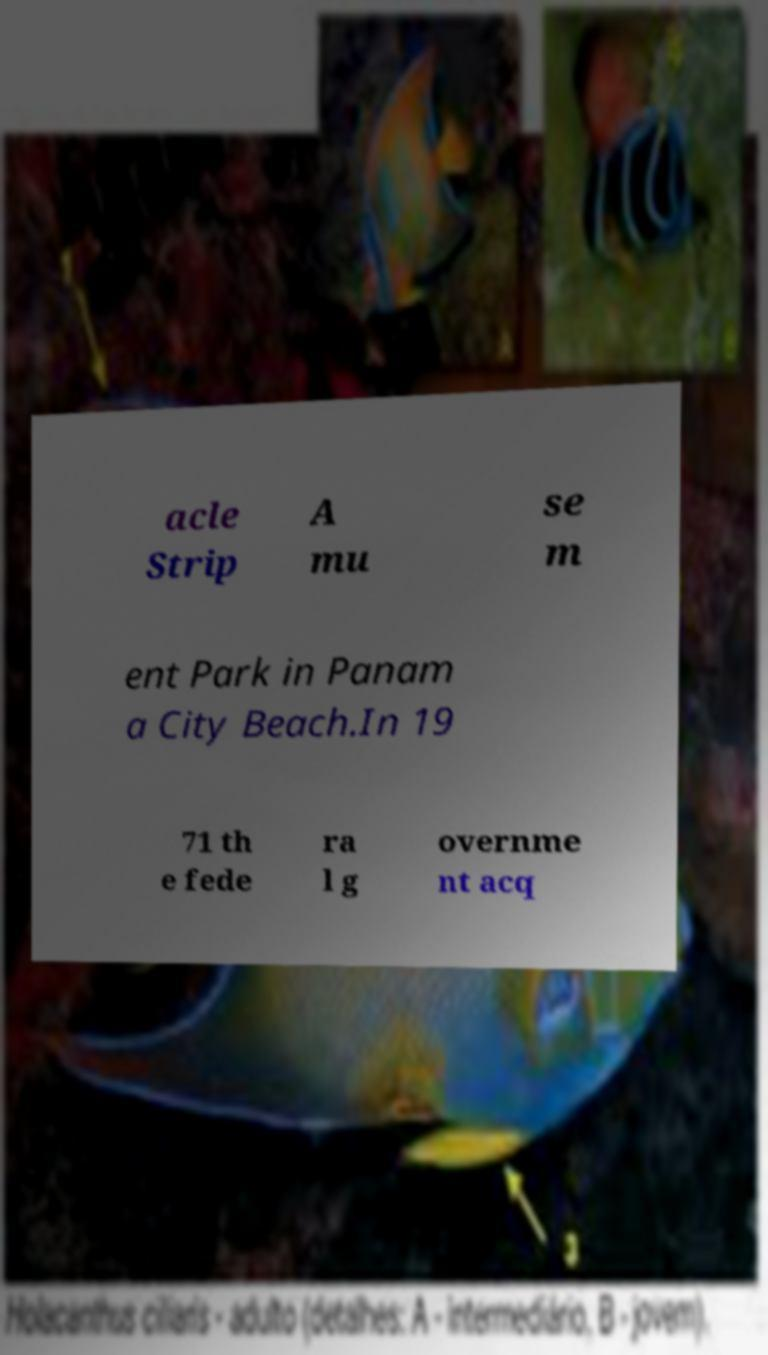There's text embedded in this image that I need extracted. Can you transcribe it verbatim? acle Strip A mu se m ent Park in Panam a City Beach.In 19 71 th e fede ra l g overnme nt acq 